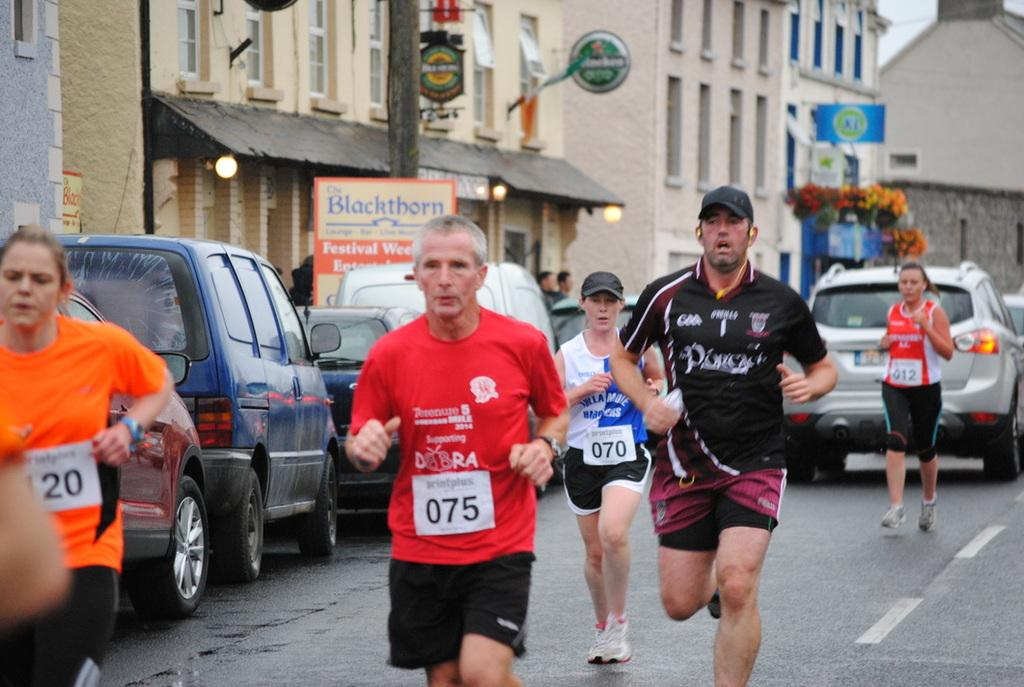<image>
Render a clear and concise summary of the photo. A runner in a red shirt is runner number 75 